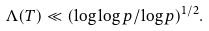<formula> <loc_0><loc_0><loc_500><loc_500>\Lambda ( T ) \ll ( \log \log p / \log p ) ^ { 1 / 2 } .</formula> 